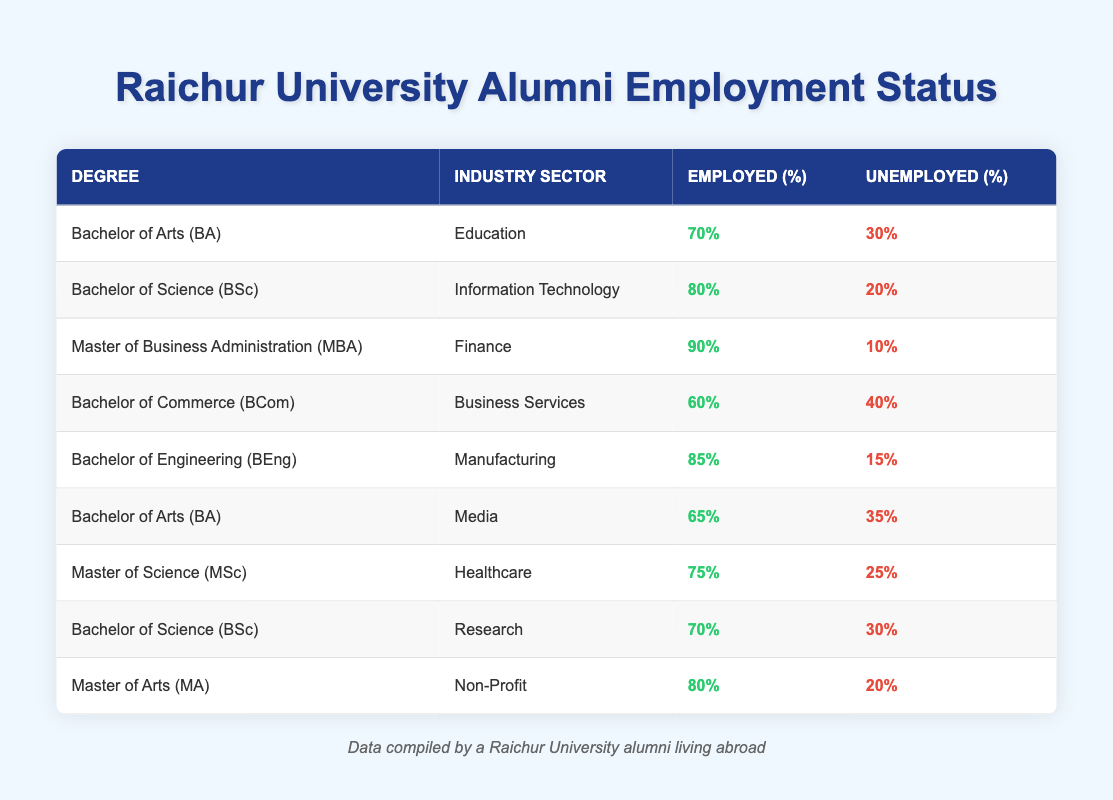What percentage of Bachelor of Commerce graduates are unemployed in Business Services? From the table, the Bachelor of Commerce (BCom) in the Business Services sector has 40% unemployed listed directly next to it.
Answer: 40% Which degree has the highest percentage of employed graduates? In the table, the Master of Business Administration (MBA) in Finance shows 90% employed, which is the highest employment percentage compared to other degrees.
Answer: 90% What is the average employment rate of graduates with a Bachelor of Arts (BA)? There are two entries for Bachelor of Arts: one in Education with 70% employed and one in Media with 65% employed. To find the average, calculate (70 + 65) / 2 = 67.5.
Answer: 67.5 Is it true that graduates with a Master of Arts (MA) have a higher unemployment rate than those with a Bachelor of Engineering (BEng)? The Master of Arts has 20% unemployed while the Bachelor of Engineering has 15% unemployed. Since 20% > 15%, it is true that MA graduates have a higher unemployment rate.
Answer: Yes What percentage of employed graduates come from the Information Technology sector? From the table, the Bachelor of Science (BSc) in Information Technology notes 80% employed. Thus, the percentage of employed graduates from this sector is 80%.
Answer: 80% How many degrees have an employed percentage of at least 75%? Looking at the table, the degrees with at least 75% employed are MBA (90%), BEng (85%), BSc in IT (80%), MA (80%), and MSc (75%). This totals to five degrees.
Answer: 5 What is the difference in unemployment rates between Bachelor of Arts graduates in Media and Healthcare? The Bachelor of Arts in Media has 35% unemployed, and the Master of Science in Healthcare has 25% unemployed. The difference is 35% - 25% = 10%.
Answer: 10% Do more graduates from the Manufacturing industry have jobs compared to those from the Education industry? The Bachelor of Engineering in Manufacturing has 85% employed, while the Bachelor of Arts in Education has 70% employed. Since 85% > 70%, more graduates from Manufacturing have jobs.
Answer: Yes What is the total number of unemployed graduates across all listed degrees? To find the total, add up the unemployed percentages: 30 (BA) + 20 (BSc IT) + 10 (MBA) + 40 (BCom) + 15 (BEng) + 35 (BA Media) + 25 (MSc) + 30 (BSc Research) + 20 (MA) =  320% unemployed.
Answer: 320% 